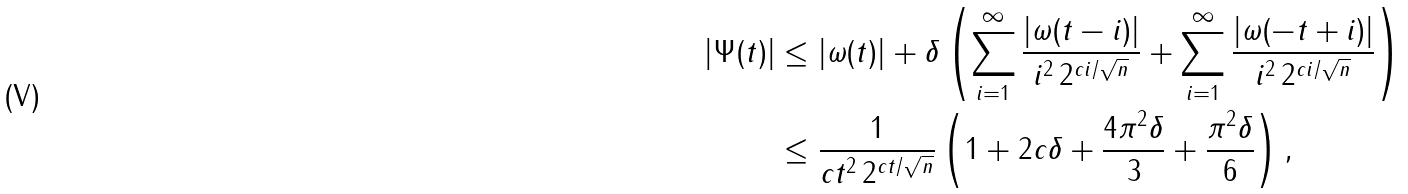Convert formula to latex. <formula><loc_0><loc_0><loc_500><loc_500>| \Psi ( t ) | & \leq | \omega ( t ) | + \delta \left ( \sum _ { i = 1 } ^ { \infty } \frac { | \omega ( t - i ) | } { i ^ { 2 } \, 2 ^ { c i / \sqrt { n } } } + \sum _ { i = 1 } ^ { \infty } \frac { | \omega ( - t + i ) | } { i ^ { 2 } \, 2 ^ { c i / \sqrt { n } } } \right ) \\ & \leq \frac { 1 } { c t ^ { 2 } \, 2 ^ { c t / \sqrt { n } } } \left ( 1 + 2 c \delta + \frac { 4 \pi ^ { 2 } \delta } { 3 } + \frac { \pi ^ { 2 } \delta } { 6 } \right ) ,</formula> 